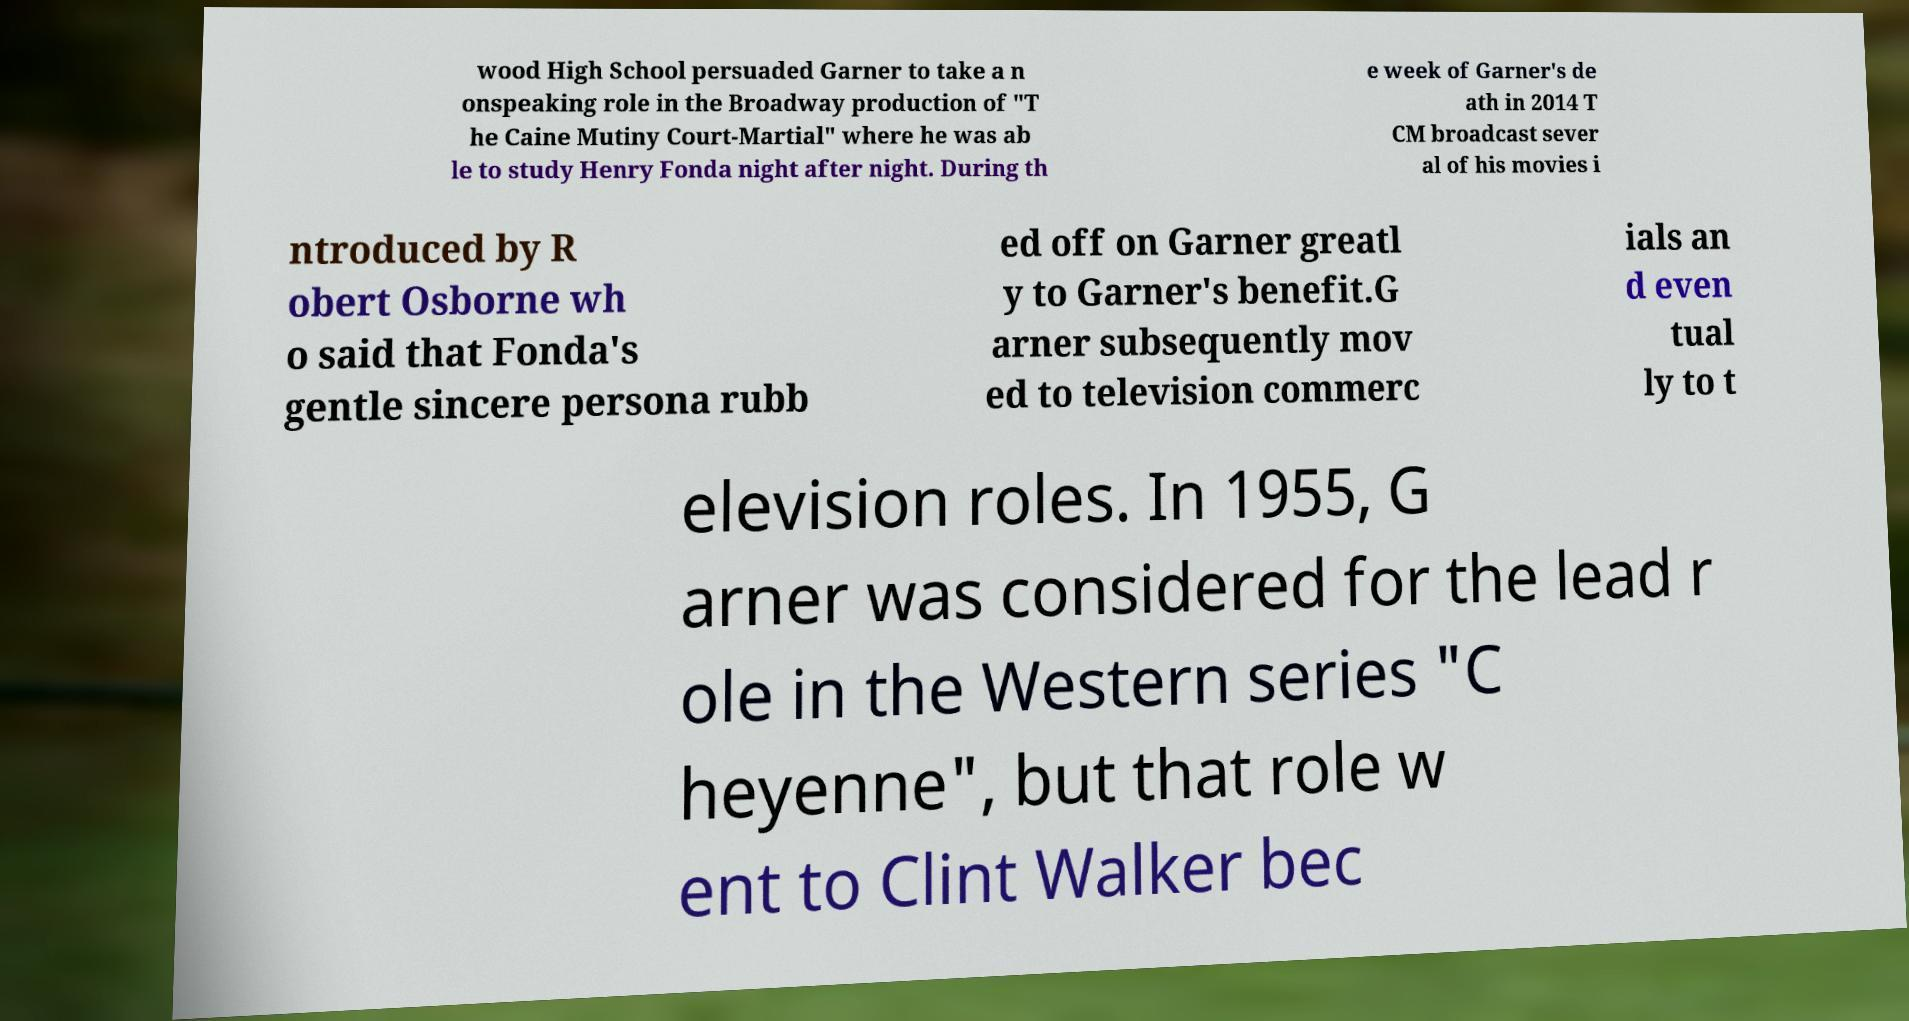Could you assist in decoding the text presented in this image and type it out clearly? wood High School persuaded Garner to take a n onspeaking role in the Broadway production of "T he Caine Mutiny Court-Martial" where he was ab le to study Henry Fonda night after night. During th e week of Garner's de ath in 2014 T CM broadcast sever al of his movies i ntroduced by R obert Osborne wh o said that Fonda's gentle sincere persona rubb ed off on Garner greatl y to Garner's benefit.G arner subsequently mov ed to television commerc ials an d even tual ly to t elevision roles. In 1955, G arner was considered for the lead r ole in the Western series "C heyenne", but that role w ent to Clint Walker bec 